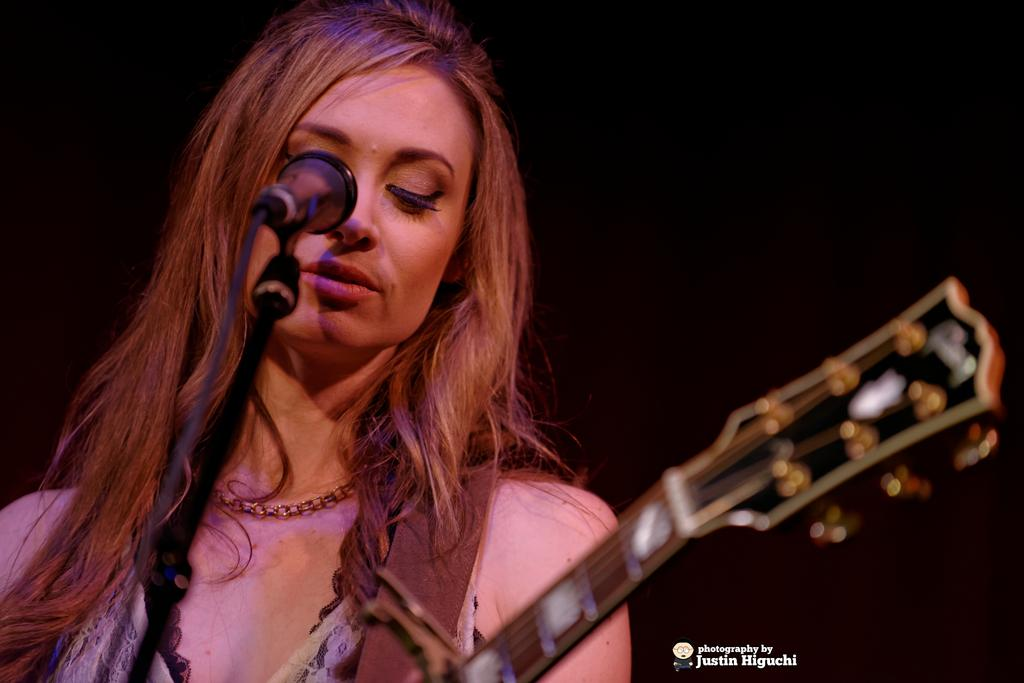Who is the main subject in the image? There is a woman in the image. What is the woman wearing around her neck? The woman is wearing a chain on her neck. What can be seen in the right corner of the image? There is text written in the right corner of the image. What object is visible in front of the woman? A microphone (mike) is visible in front of the woman. What type of comb is the woman using in the image? There is no comb present in the image. What type of approval is the woman seeking in the image? There is no indication of approval-seeking in the image. What is the woman doing with her tongue in the image? There is no mention of the woman's tongue in the image. 